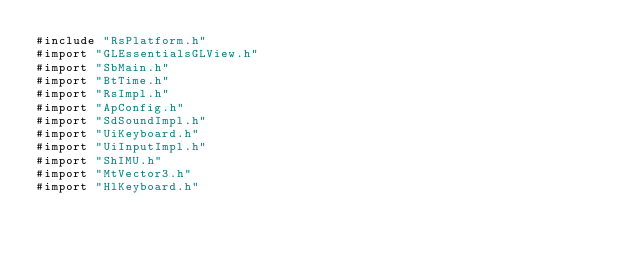Convert code to text. <code><loc_0><loc_0><loc_500><loc_500><_ObjectiveC_>#include "RsPlatform.h"
#import "GLEssentialsGLView.h"
#import "SbMain.h"
#import "BtTime.h"
#import "RsImpl.h"
#import "ApConfig.h"
#import "SdSoundImpl.h"
#import "UiKeyboard.h"
#import "UiInputImpl.h"
#import "ShIMU.h"
#import "MtVector3.h"
#import "HlKeyboard.h"</code> 